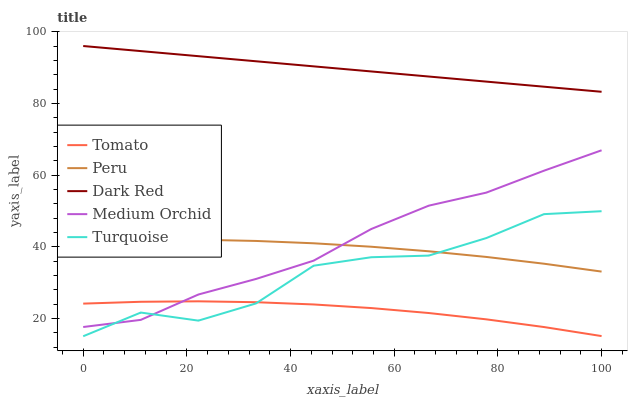Does Tomato have the minimum area under the curve?
Answer yes or no. Yes. Does Dark Red have the maximum area under the curve?
Answer yes or no. Yes. Does Turquoise have the minimum area under the curve?
Answer yes or no. No. Does Turquoise have the maximum area under the curve?
Answer yes or no. No. Is Dark Red the smoothest?
Answer yes or no. Yes. Is Turquoise the roughest?
Answer yes or no. Yes. Is Turquoise the smoothest?
Answer yes or no. No. Is Dark Red the roughest?
Answer yes or no. No. Does Turquoise have the lowest value?
Answer yes or no. Yes. Does Dark Red have the lowest value?
Answer yes or no. No. Does Dark Red have the highest value?
Answer yes or no. Yes. Does Turquoise have the highest value?
Answer yes or no. No. Is Tomato less than Dark Red?
Answer yes or no. Yes. Is Peru greater than Tomato?
Answer yes or no. Yes. Does Tomato intersect Turquoise?
Answer yes or no. Yes. Is Tomato less than Turquoise?
Answer yes or no. No. Is Tomato greater than Turquoise?
Answer yes or no. No. Does Tomato intersect Dark Red?
Answer yes or no. No. 